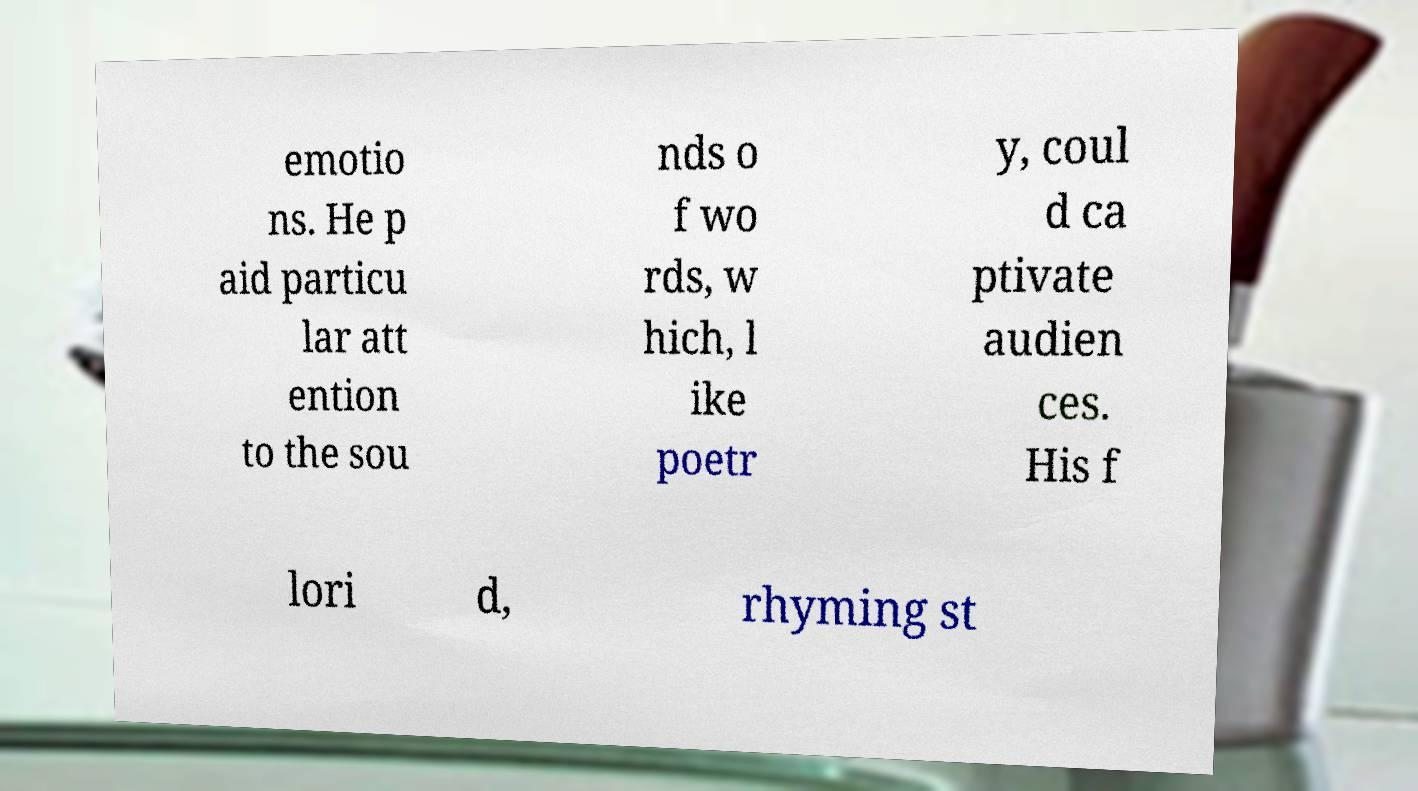There's text embedded in this image that I need extracted. Can you transcribe it verbatim? emotio ns. He p aid particu lar att ention to the sou nds o f wo rds, w hich, l ike poetr y, coul d ca ptivate audien ces. His f lori d, rhyming st 